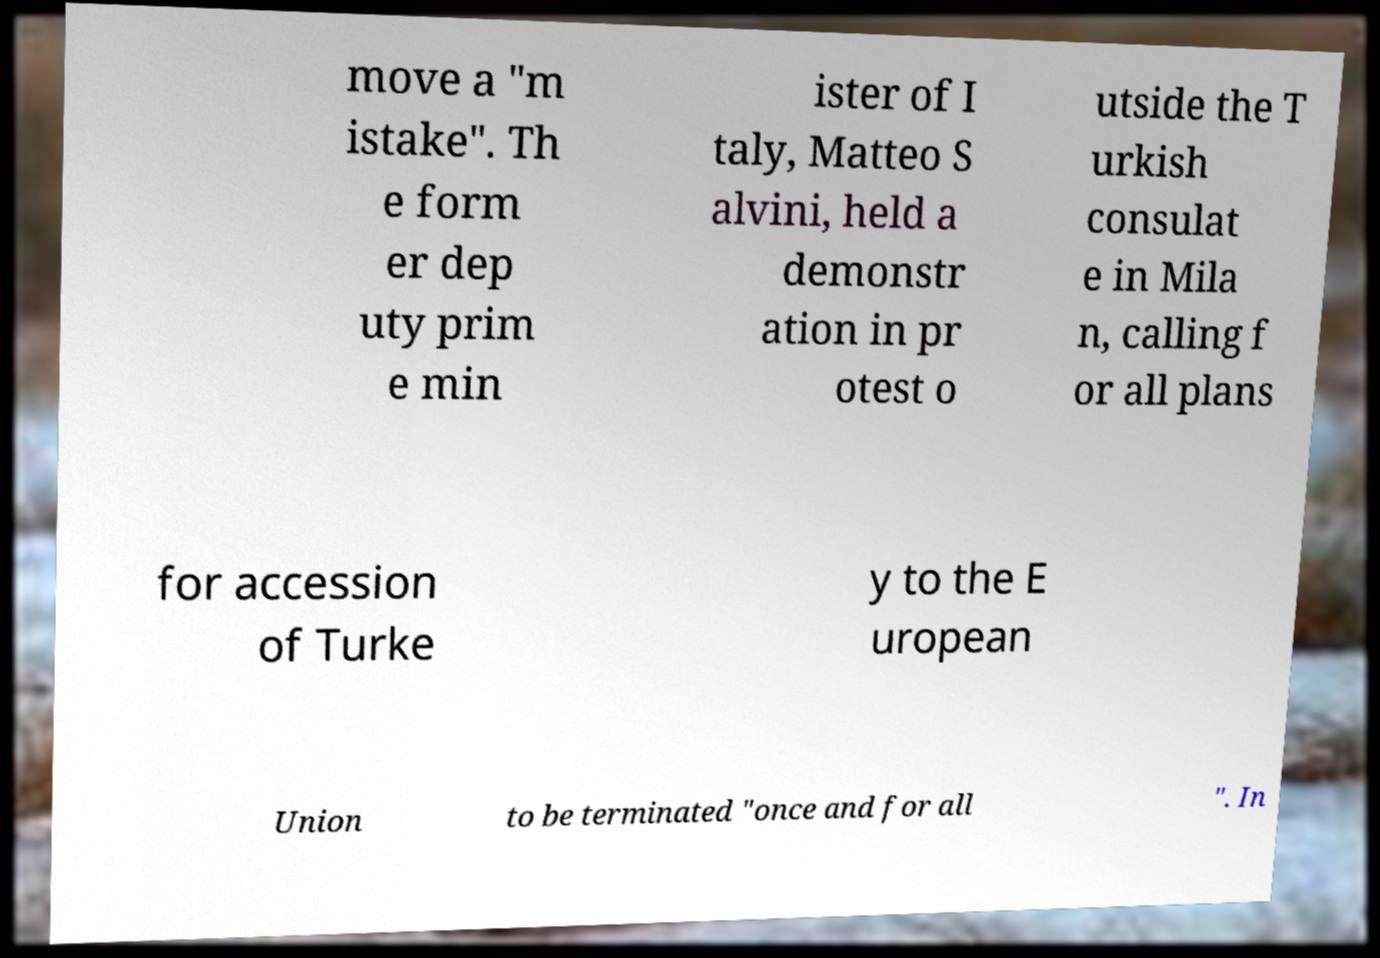What messages or text are displayed in this image? I need them in a readable, typed format. move a "m istake". Th e form er dep uty prim e min ister of I taly, Matteo S alvini, held a demonstr ation in pr otest o utside the T urkish consulat e in Mila n, calling f or all plans for accession of Turke y to the E uropean Union to be terminated "once and for all ". In 